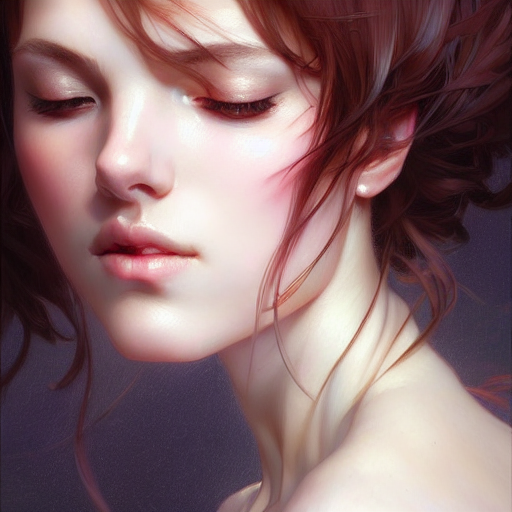What emotion does the subject of this image seem to be expressing? The subject appears to convey a sense of serene contemplation, with a soft gaze and a gentle tilt of the head that might suggest introspection or calmness. 